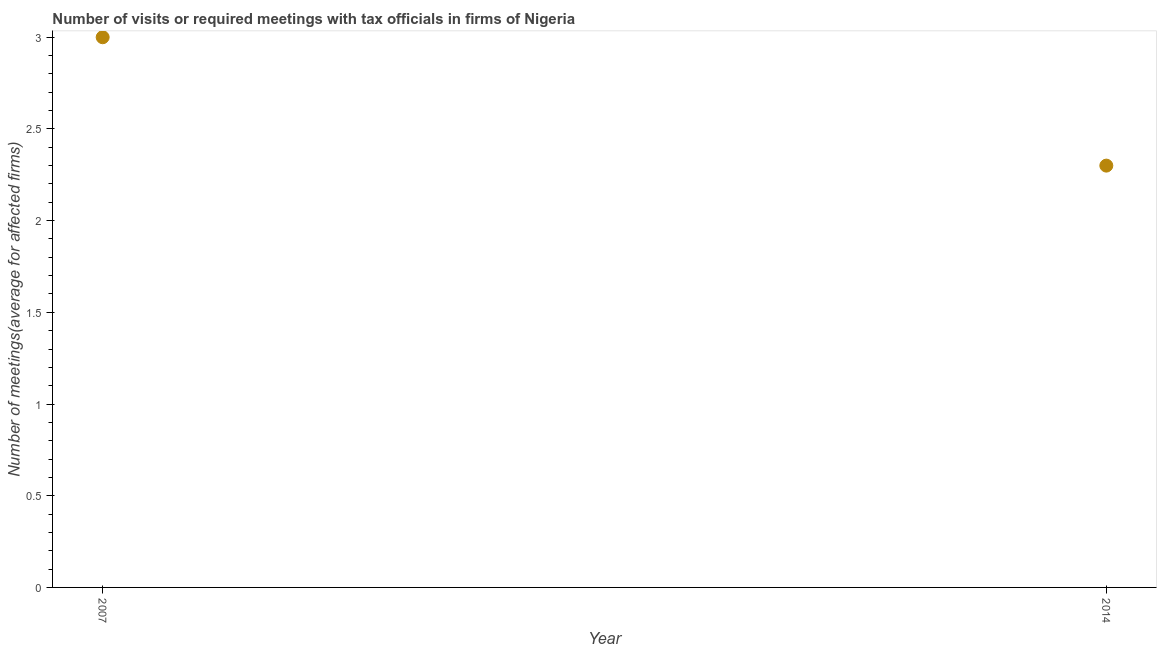In which year was the number of required meetings with tax officials minimum?
Your response must be concise. 2014. What is the sum of the number of required meetings with tax officials?
Keep it short and to the point. 5.3. What is the difference between the number of required meetings with tax officials in 2007 and 2014?
Your answer should be compact. 0.7. What is the average number of required meetings with tax officials per year?
Offer a very short reply. 2.65. What is the median number of required meetings with tax officials?
Your answer should be compact. 2.65. Do a majority of the years between 2007 and 2014 (inclusive) have number of required meetings with tax officials greater than 0.6 ?
Offer a very short reply. Yes. What is the ratio of the number of required meetings with tax officials in 2007 to that in 2014?
Provide a short and direct response. 1.3. Does the number of required meetings with tax officials monotonically increase over the years?
Your answer should be compact. No. How many years are there in the graph?
Offer a very short reply. 2. What is the difference between two consecutive major ticks on the Y-axis?
Give a very brief answer. 0.5. Are the values on the major ticks of Y-axis written in scientific E-notation?
Offer a terse response. No. Does the graph contain any zero values?
Offer a terse response. No. What is the title of the graph?
Make the answer very short. Number of visits or required meetings with tax officials in firms of Nigeria. What is the label or title of the Y-axis?
Ensure brevity in your answer.  Number of meetings(average for affected firms). What is the ratio of the Number of meetings(average for affected firms) in 2007 to that in 2014?
Your response must be concise. 1.3. 